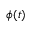<formula> <loc_0><loc_0><loc_500><loc_500>\phi ( t )</formula> 